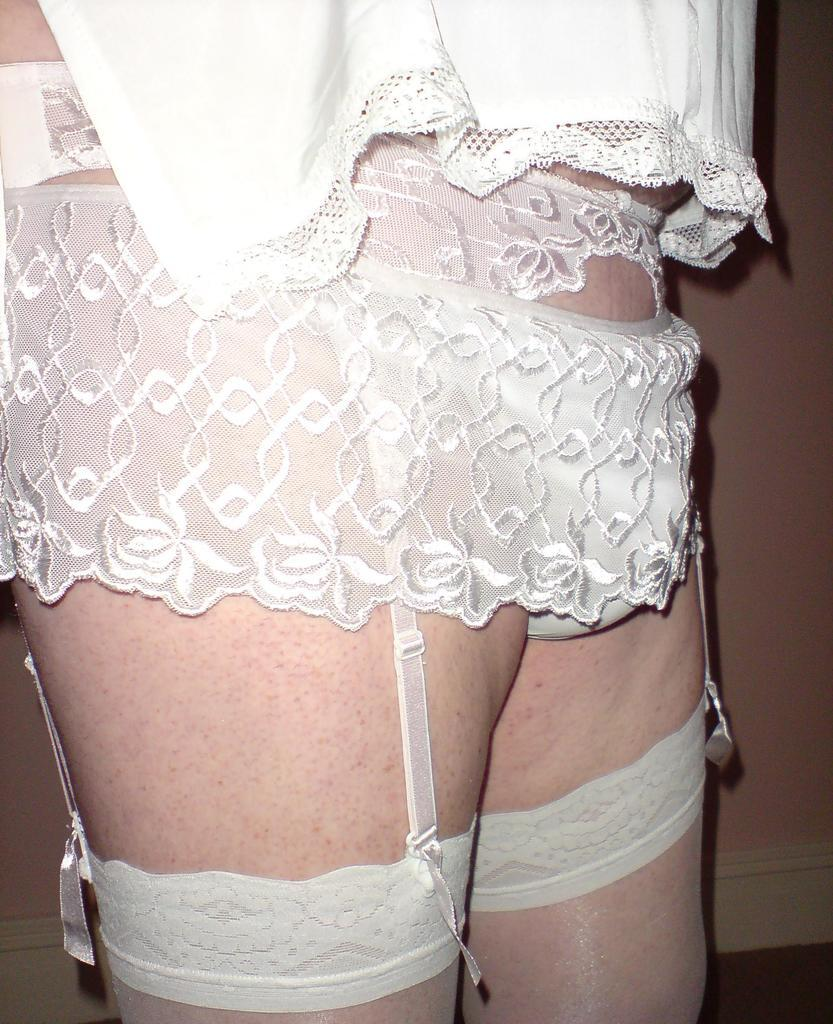What is the main subject of the image? There is a person standing in the image. Can you describe the person's clothing? The person is wearing white clothes. What can be seen in the background of the image? There is a wall in the image. How many bees are sitting on the person's shoulder in the image? There are no bees present in the image. What type of pig can be seen in the image? There is no pig present in the image. 